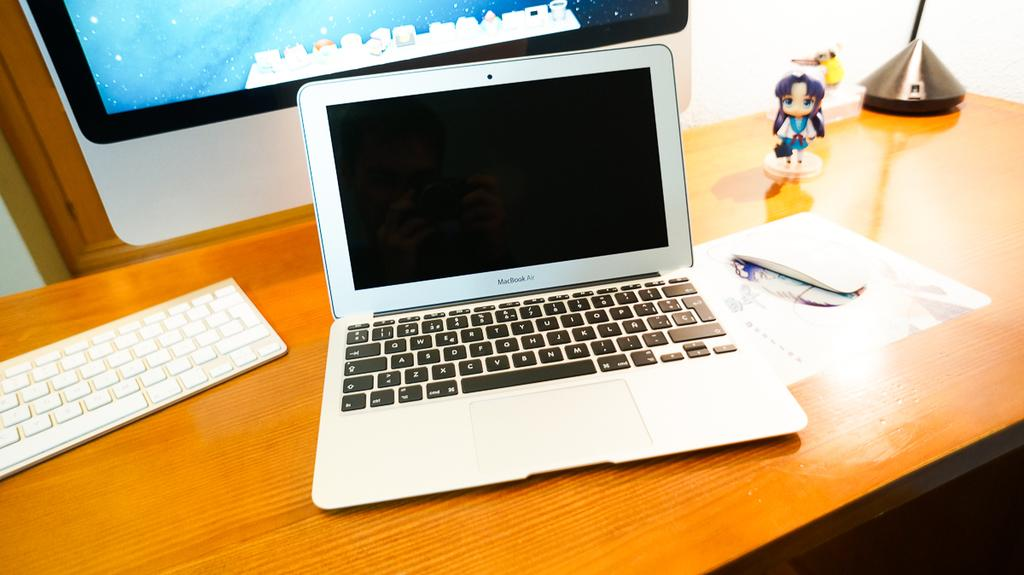<image>
Summarize the visual content of the image. a MacBook Air computer on a desk in front of a larger monitor 